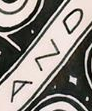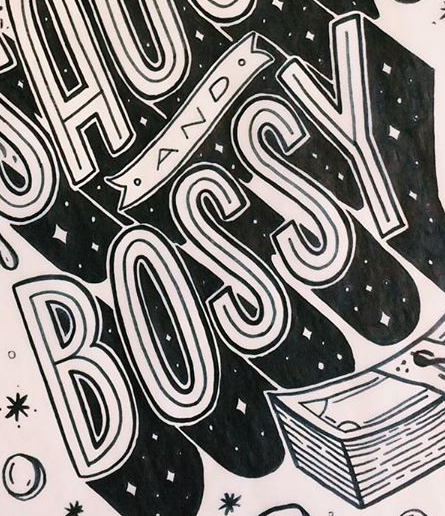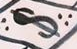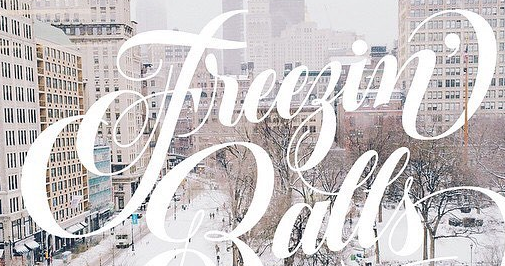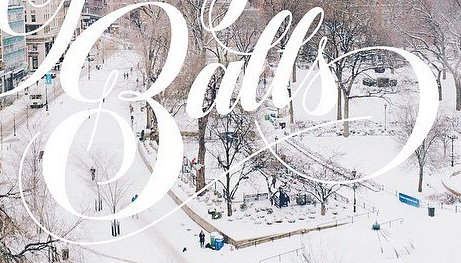What text appears in these images from left to right, separated by a semicolon? AND; BOSSY; $; Freegin'; Balls 